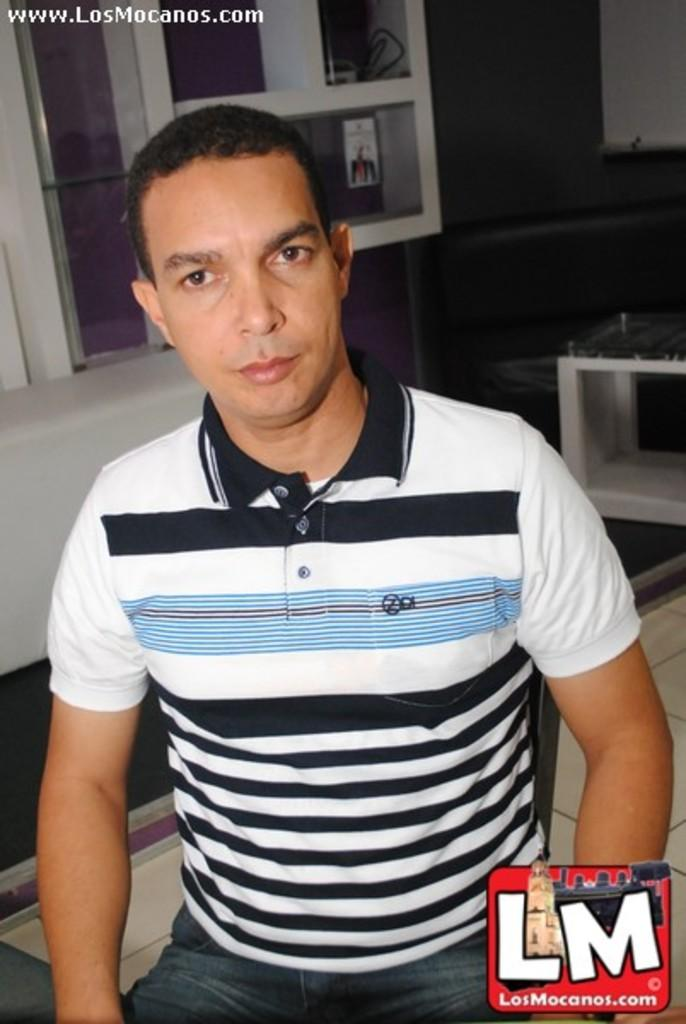Provide a one-sentence caption for the provided image. sitting guy with striped shirt and website of www.losmocanos.com at top of picture and LM at bottom right. 